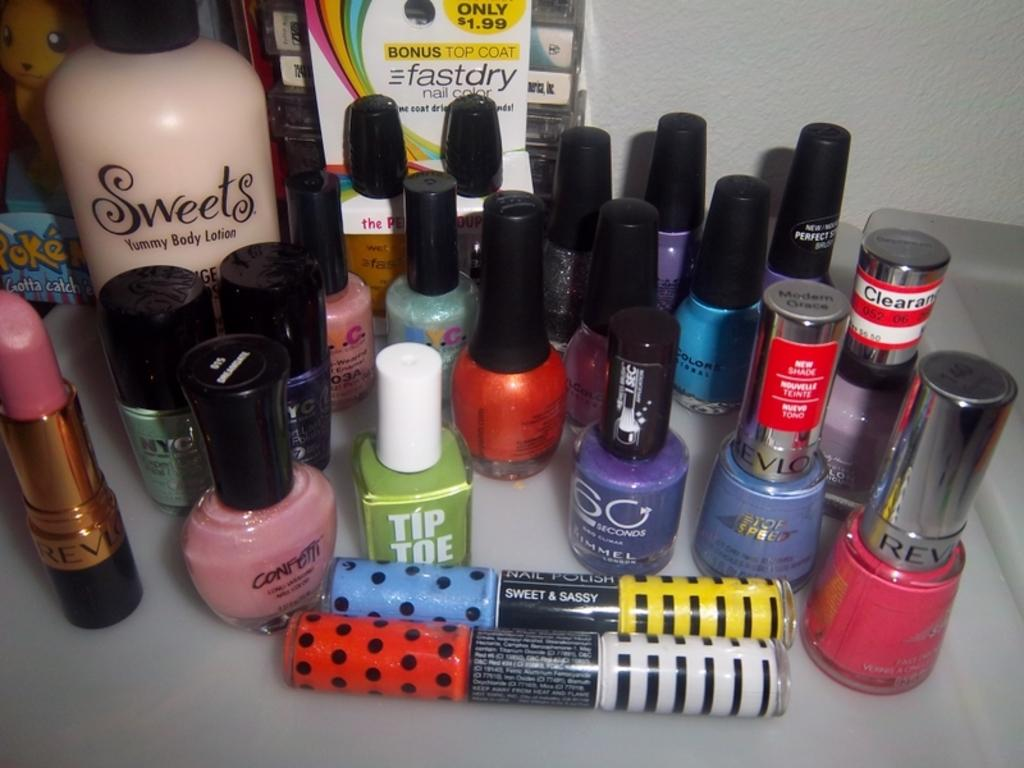<image>
Render a clear and concise summary of the photo. A green color nail polish called Tip Toe sits in front. 